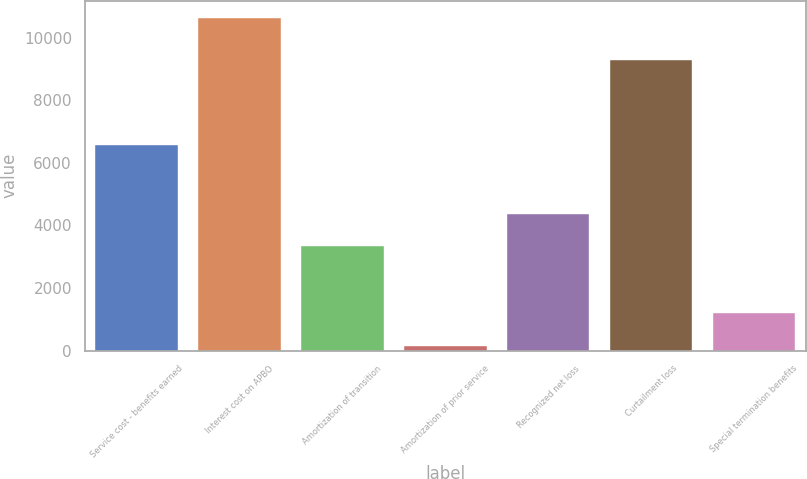Convert chart. <chart><loc_0><loc_0><loc_500><loc_500><bar_chart><fcel>Service cost - benefits earned<fcel>Interest cost on APBO<fcel>Amortization of transition<fcel>Amortization of prior service<fcel>Recognized net loss<fcel>Curtailment loss<fcel>Special termination benefits<nl><fcel>6560<fcel>10637<fcel>3327<fcel>143<fcel>4376.4<fcel>9276<fcel>1192.4<nl></chart> 